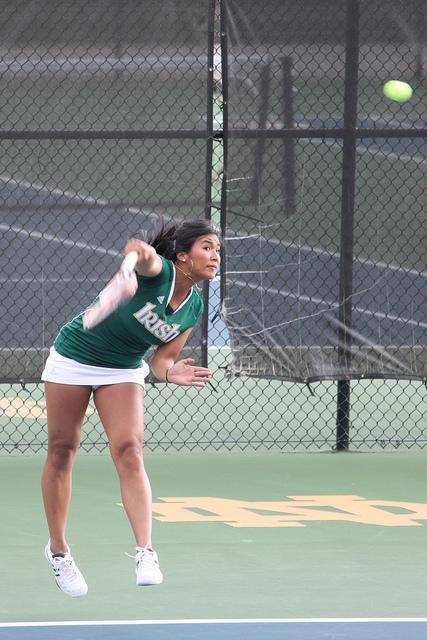What color skirt is she wearing?
Quick response, please. White. What sport is this person playing?
Short answer required. Tennis. What is this person holding?
Write a very short answer. Racket. Is she reaching downwards?
Quick response, please. No. What color is her skirt?
Quick response, please. White. Why is the woman in the foreground not moving?
Give a very brief answer. Just served. Should this lady be wearing earrings on the tennis court?
Write a very short answer. No. What did the girl just do?
Concise answer only. Hit ball. What is on the woman's wrist?
Short answer required. Bracelet. What type of footwear is the girl wearing?
Give a very brief answer. Sneakers. What color is the ball?
Quick response, please. Green. What country does her clothing advertise?
Keep it brief. Ireland. 